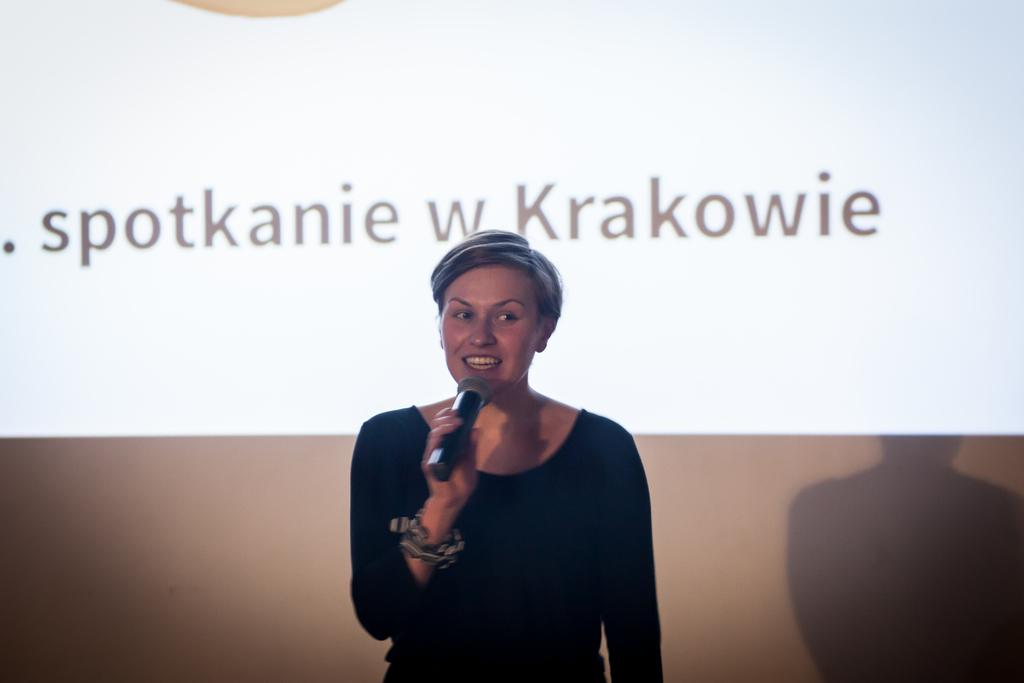Who is the main subject in the image? There is a woman in the image. What is the woman doing in the image? The woman is standing and speaking. What object is the woman holding in the image? The woman is holding a microphone. What can be seen behind the woman in the image? There is a projected screen behind the woman. What type of trucks can be seen driving past the woman in the image? There are no trucks visible in the image. Is the woman using bait to attract any animals in the image? There is no mention of bait or animals in the image. 